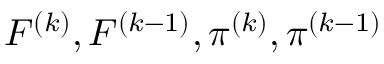Convert formula to latex. <formula><loc_0><loc_0><loc_500><loc_500>F ^ { ( k ) } , F ^ { ( k - 1 ) } , \pi ^ { ( k ) } , \pi ^ { ( k - 1 ) }</formula> 